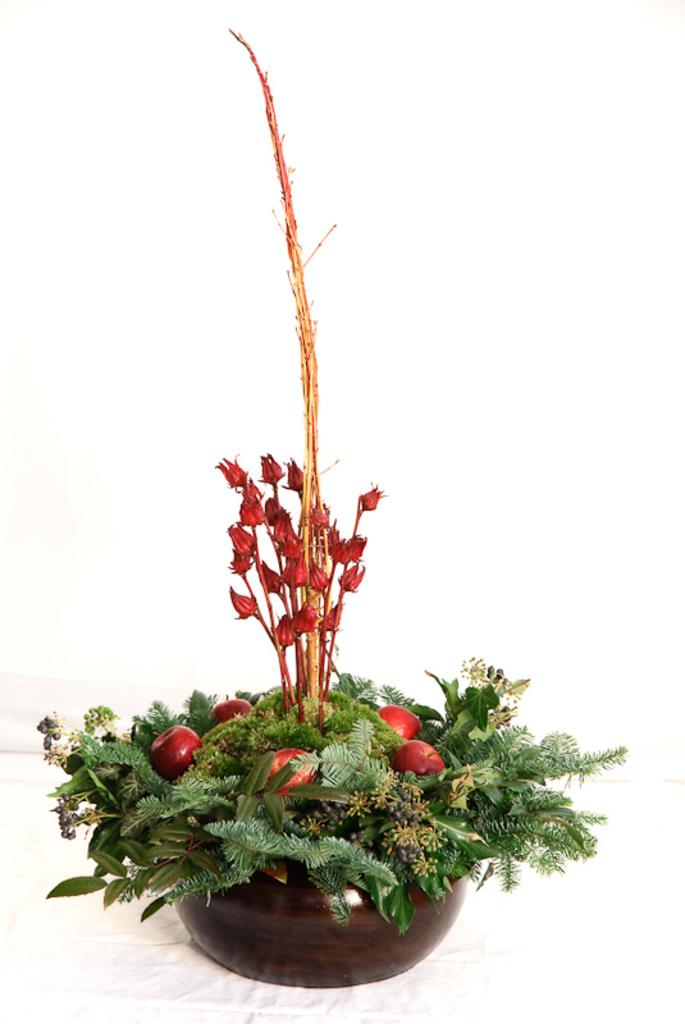What type of plant life is visible in the image? There are green leaves, red fruits, and red flowers visible in the image. What color is the pot that the plants are in? The plants are in a brown color pot. What is the background color of the image? The background of the image is white. What is the opinion of the whistle in the morning, as seen in the image? There is no whistle or reference to a morning in the image; it only features plants in a pot with a white background. 